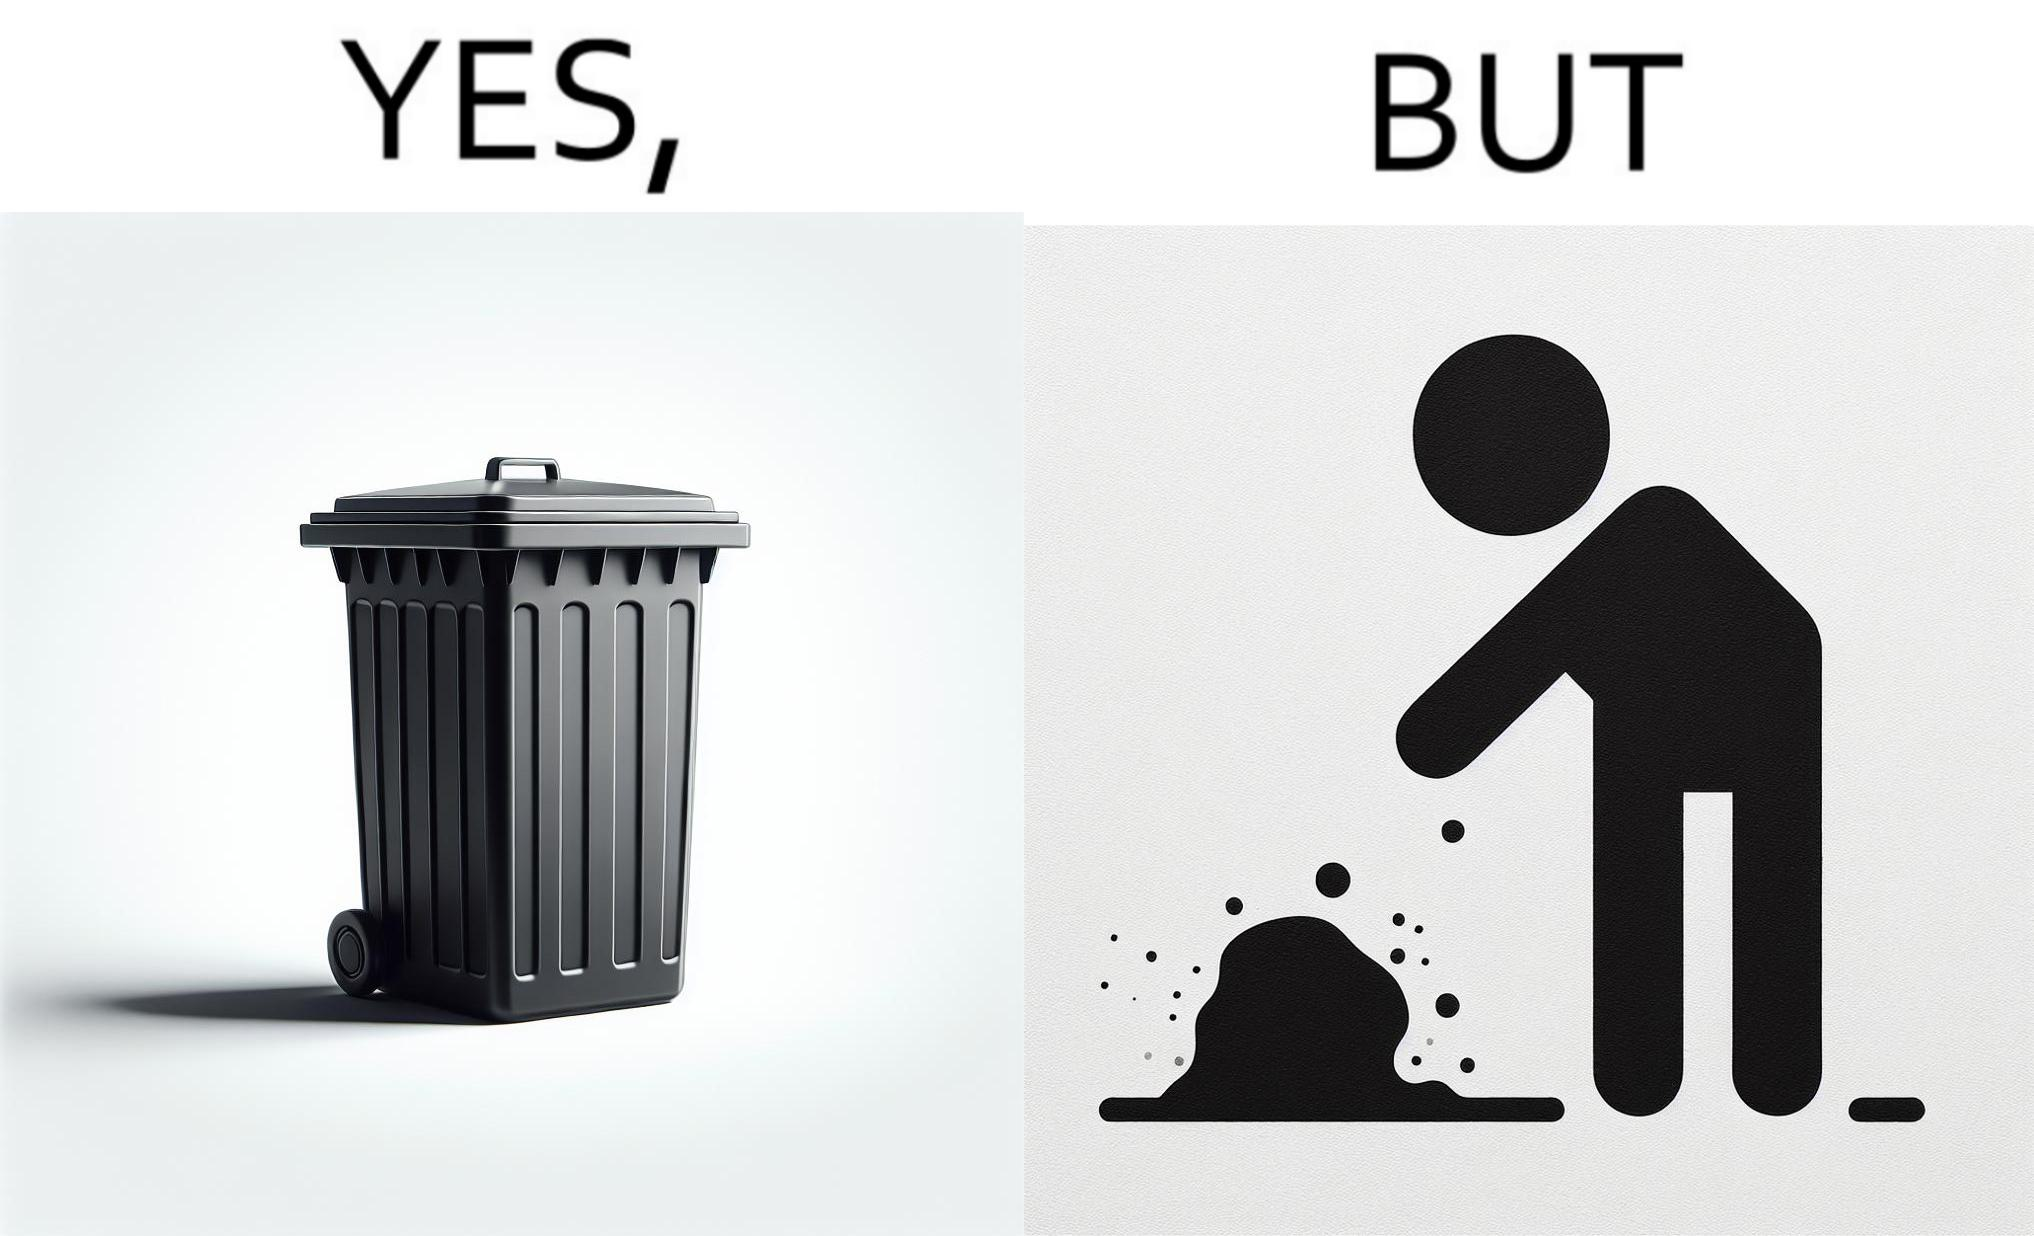Describe the satirical element in this image. The images are ironic because even though garbage bins are provided for humans to dispose waste, by habit humans still choose to make surroundings dirty by disposing garbage improperly 